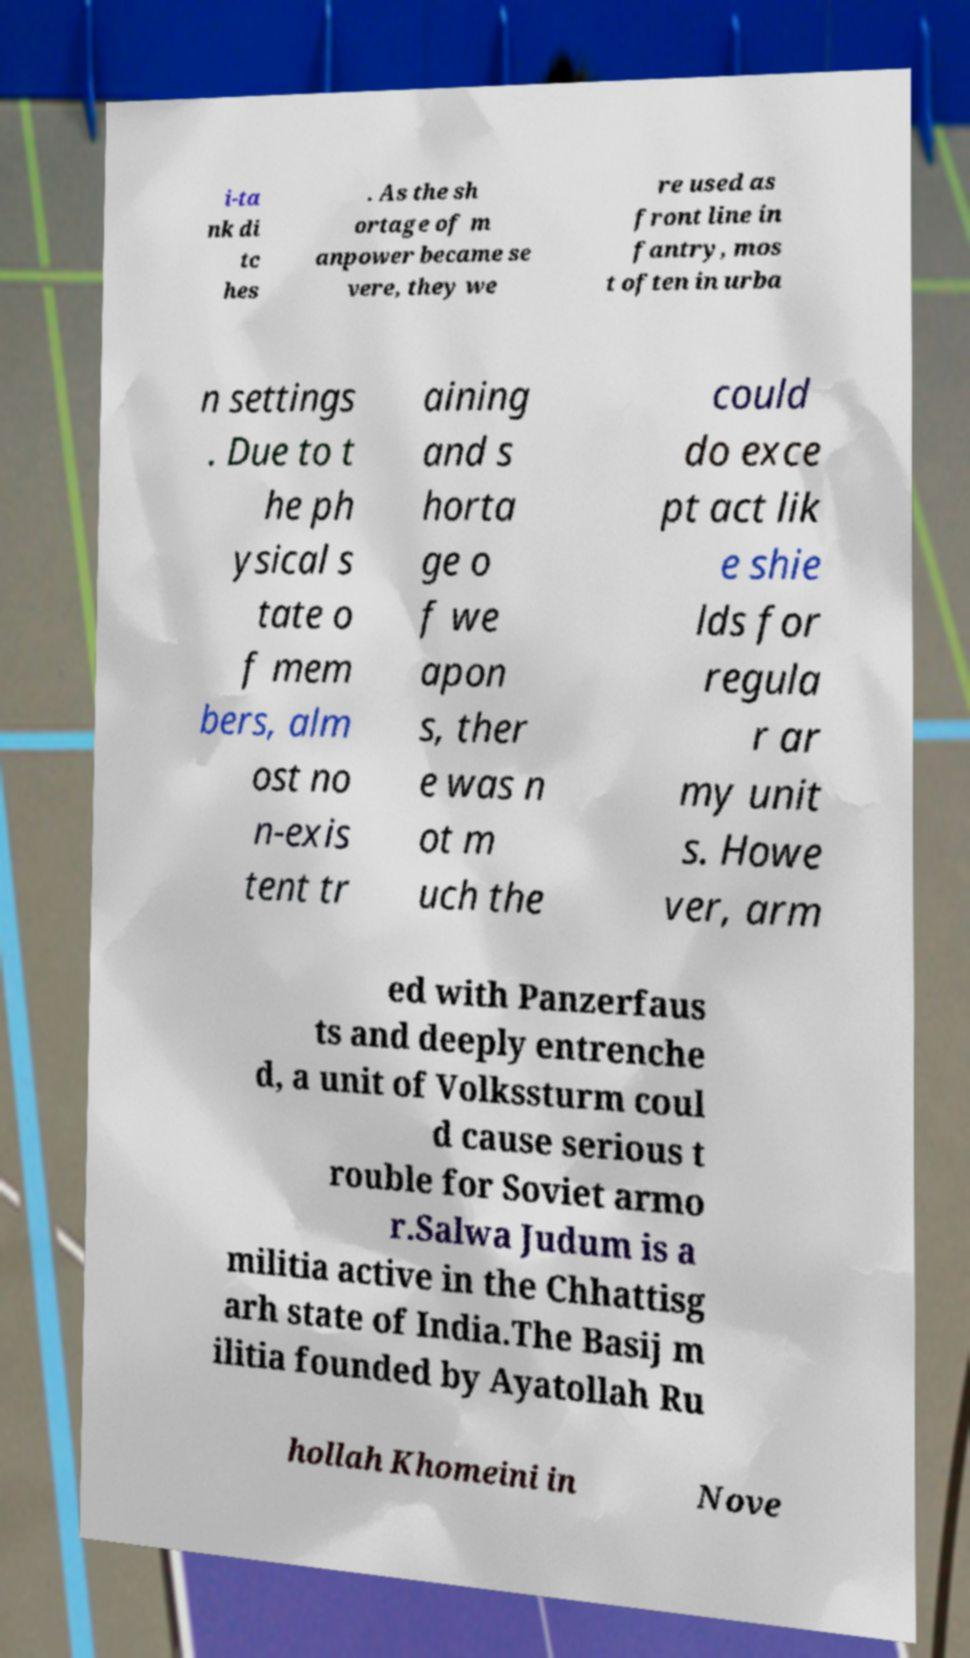For documentation purposes, I need the text within this image transcribed. Could you provide that? i-ta nk di tc hes . As the sh ortage of m anpower became se vere, they we re used as front line in fantry, mos t often in urba n settings . Due to t he ph ysical s tate o f mem bers, alm ost no n-exis tent tr aining and s horta ge o f we apon s, ther e was n ot m uch the could do exce pt act lik e shie lds for regula r ar my unit s. Howe ver, arm ed with Panzerfaus ts and deeply entrenche d, a unit of Volkssturm coul d cause serious t rouble for Soviet armo r.Salwa Judum is a militia active in the Chhattisg arh state of India.The Basij m ilitia founded by Ayatollah Ru hollah Khomeini in Nove 